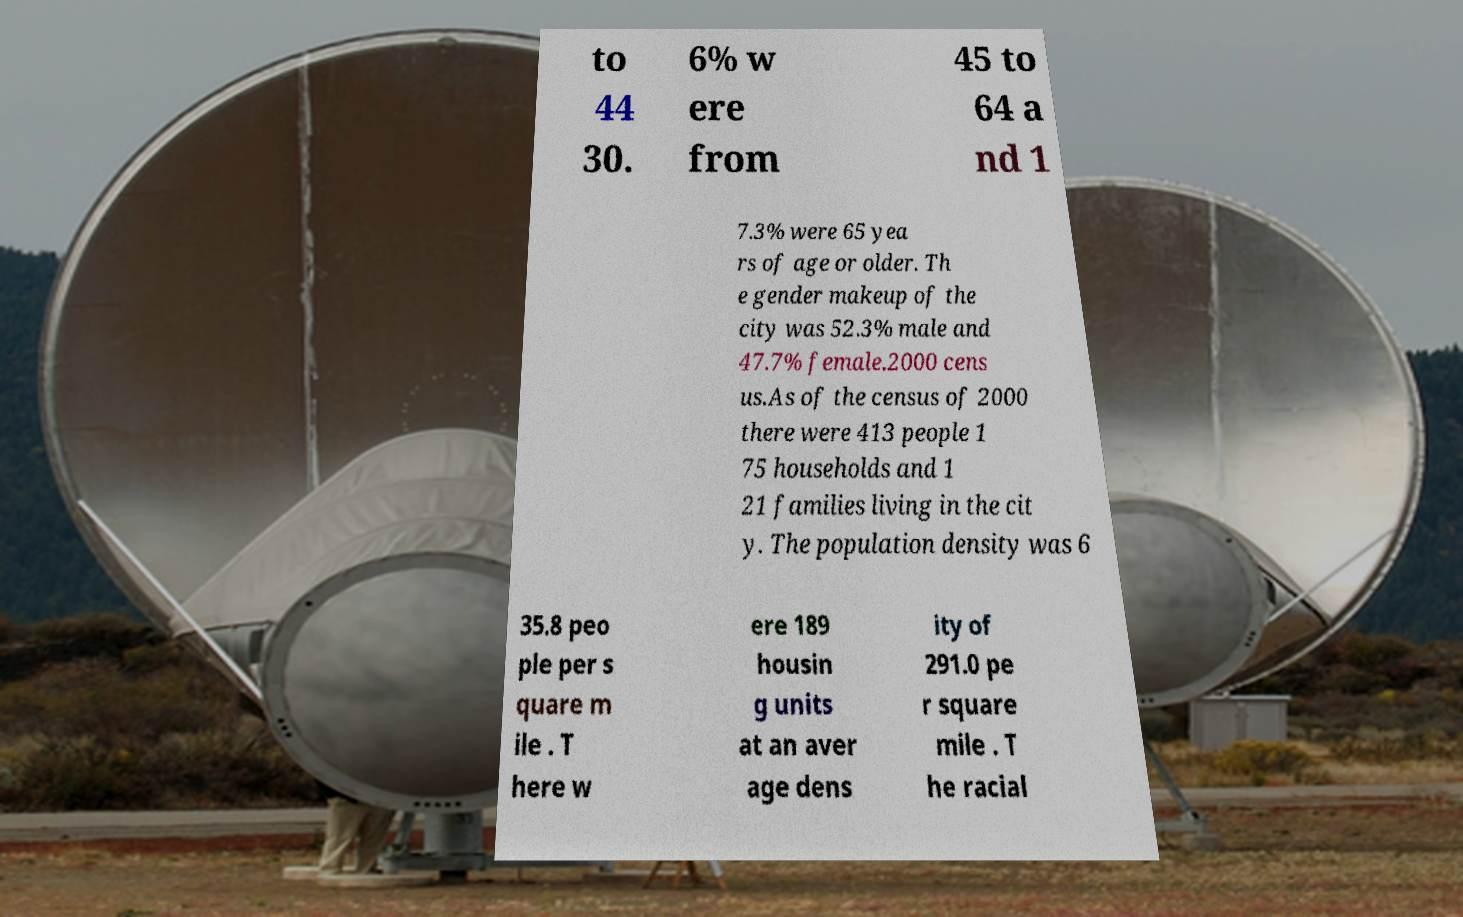There's text embedded in this image that I need extracted. Can you transcribe it verbatim? to 44 30. 6% w ere from 45 to 64 a nd 1 7.3% were 65 yea rs of age or older. Th e gender makeup of the city was 52.3% male and 47.7% female.2000 cens us.As of the census of 2000 there were 413 people 1 75 households and 1 21 families living in the cit y. The population density was 6 35.8 peo ple per s quare m ile . T here w ere 189 housin g units at an aver age dens ity of 291.0 pe r square mile . T he racial 